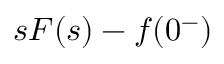<formula> <loc_0><loc_0><loc_500><loc_500>s F ( s ) - f ( 0 ^ { - } )</formula> 